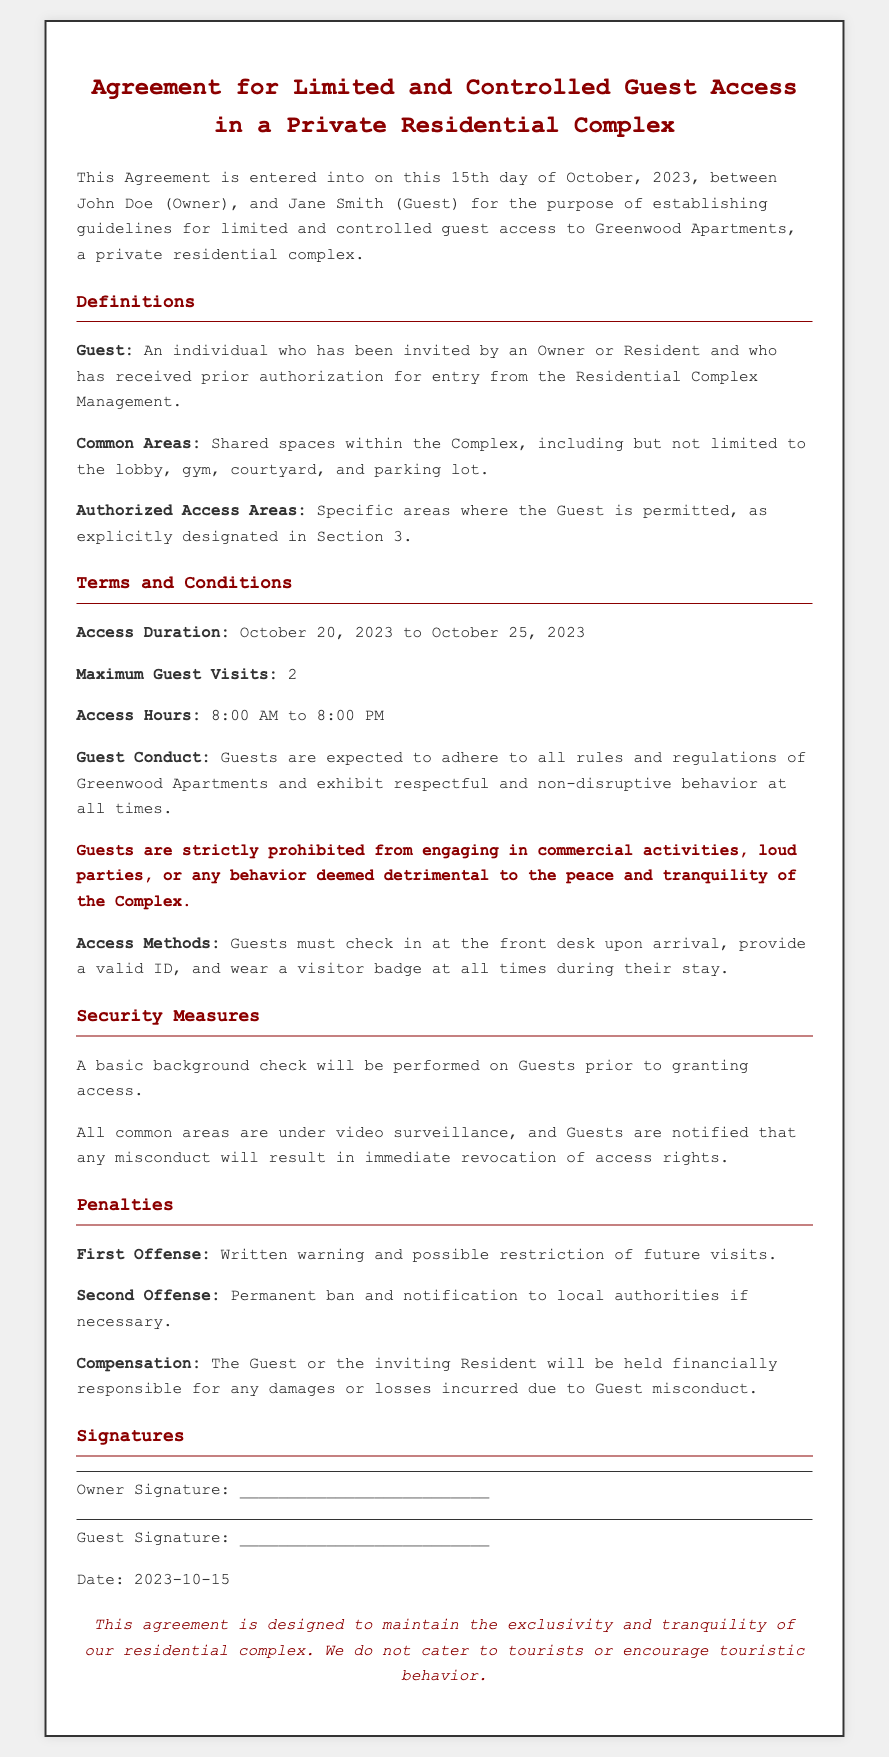What is the date of the agreement? The date of the agreement is clearly stated at the beginning of the document.
Answer: October 15, 2023 Who are the parties involved in the agreement? The agreement specifies the names of the parties at the start.
Answer: John Doe and Jane Smith What is the maximum number of guest visits allowed? The document explicitly mentions the limitation on guest visits in the terms and conditions section.
Answer: 2 What are the access hours for guests? The access hours for guests are detailed in the terms and conditions section.
Answer: 8:00 AM to 8:00 PM What is the penalty for the first offense? The penalties for guest misconduct are outlined in the penalties section of the document.
Answer: Written warning and possible restriction of future visits What is the purpose of the basic background check? The reason for performing a background check is indicated in the security measures section and is related to guest access.
Answer: Granting access What should guests do upon arrival? The access methods section describes the exact procedure guests must follow upon arrival.
Answer: Check in at the front desk Is commercial activity allowed for guests? The guest conduct section specifically addresses the types of behavior that are prohibited.
Answer: No What statement reflects the complex's stance on tourists? The final note in the document expresses a specific opinion regarding tourists.
Answer: We do not cater to tourists or encourage touristic behavior 